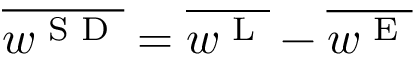<formula> <loc_0><loc_0><loc_500><loc_500>\overline { { w ^ { S D } } } = \overline { { w ^ { L } } } - \overline { { w ^ { E } } }</formula> 